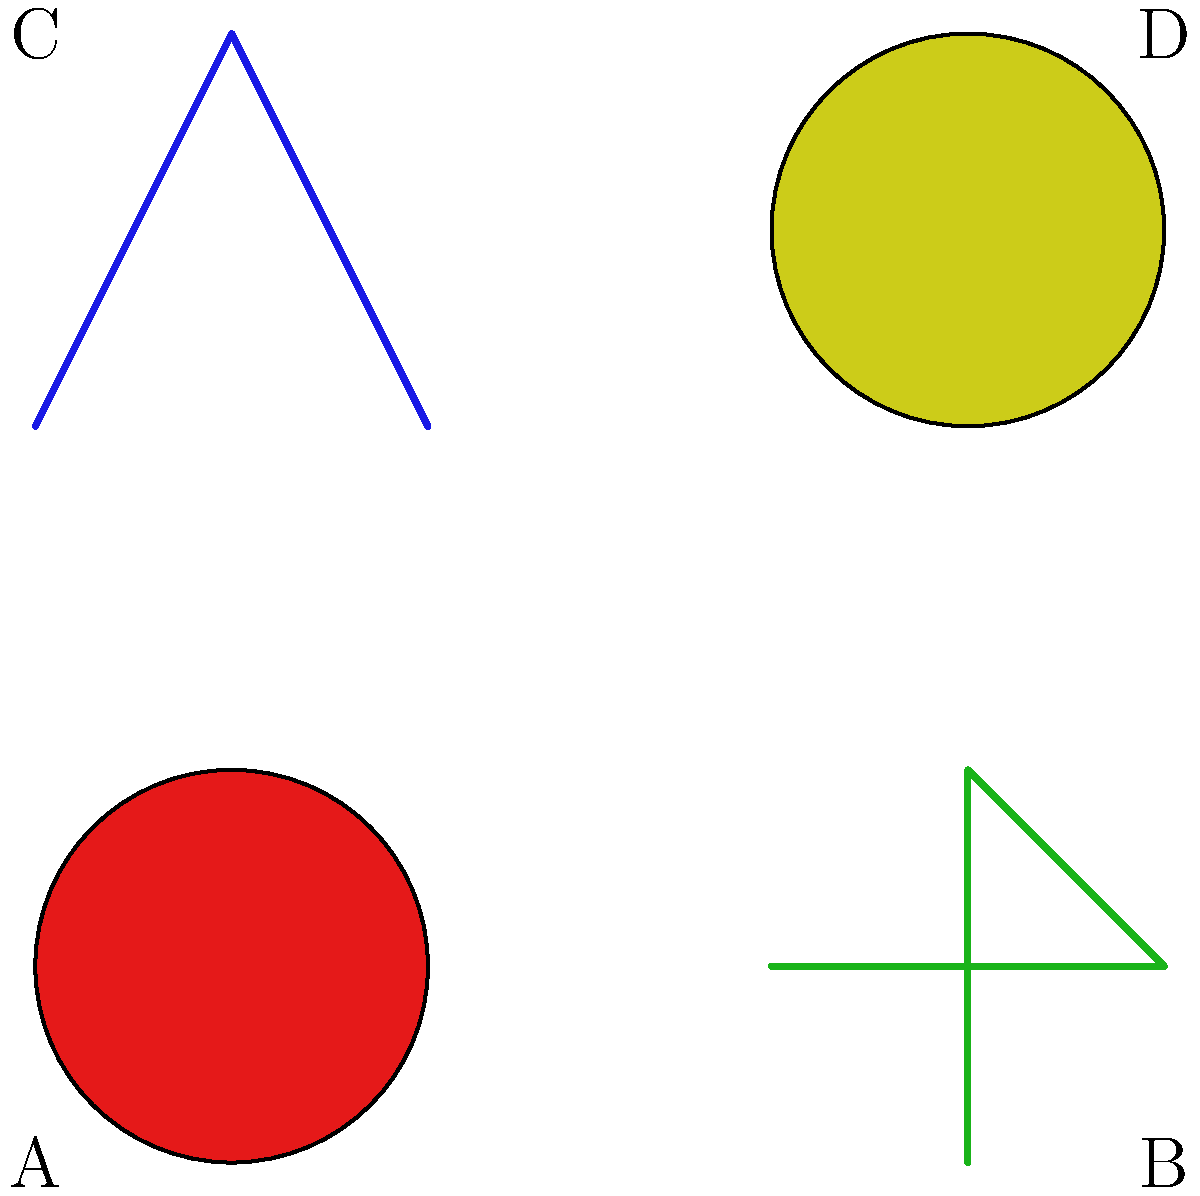As part of the comprehensive sexual education curriculum, students need to be able to identify different types of contraceptives. Which of the contraceptive methods shown in the image is considered the most effective at preventing both pregnancy and sexually transmitted infections (STIs) when used correctly? To answer this question, let's analyze each contraceptive method shown in the image:

1. A (red circle): This represents an oral contraceptive pill. While effective at preventing pregnancy when used correctly, it does not protect against STIs.

2. B (green outline): This represents a condom. Condoms, when used correctly, are highly effective at preventing both pregnancy and STIs. They create a barrier that prevents the exchange of bodily fluids.

3. C (blue T-shape): This represents an intrauterine device (IUD). IUDs are very effective at preventing pregnancy but do not protect against STIs.

4. D (yellow square): This represents a contraceptive patch. Like pills, patches are effective at preventing pregnancy but do not protect against STIs.

Among these options, condoms (B) are the only method that provides dual protection against both pregnancy and STIs when used correctly. This makes them the most effective option for comprehensive protection in this set of contraceptives.

It's important to note that while condoms are highly effective, combining methods (such as condoms with another form of birth control) can provide even greater protection against pregnancy.
Answer: Condom (B) 